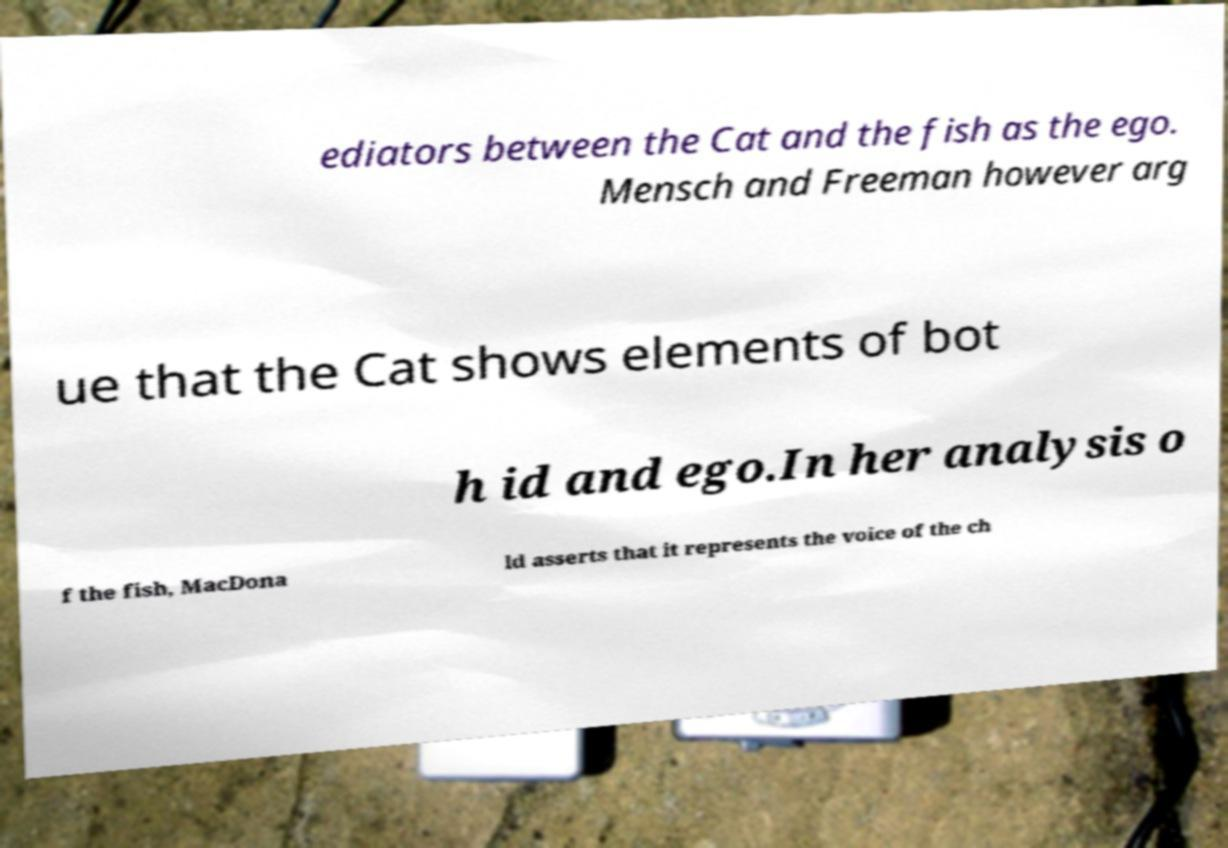Can you read and provide the text displayed in the image?This photo seems to have some interesting text. Can you extract and type it out for me? ediators between the Cat and the fish as the ego. Mensch and Freeman however arg ue that the Cat shows elements of bot h id and ego.In her analysis o f the fish, MacDona ld asserts that it represents the voice of the ch 